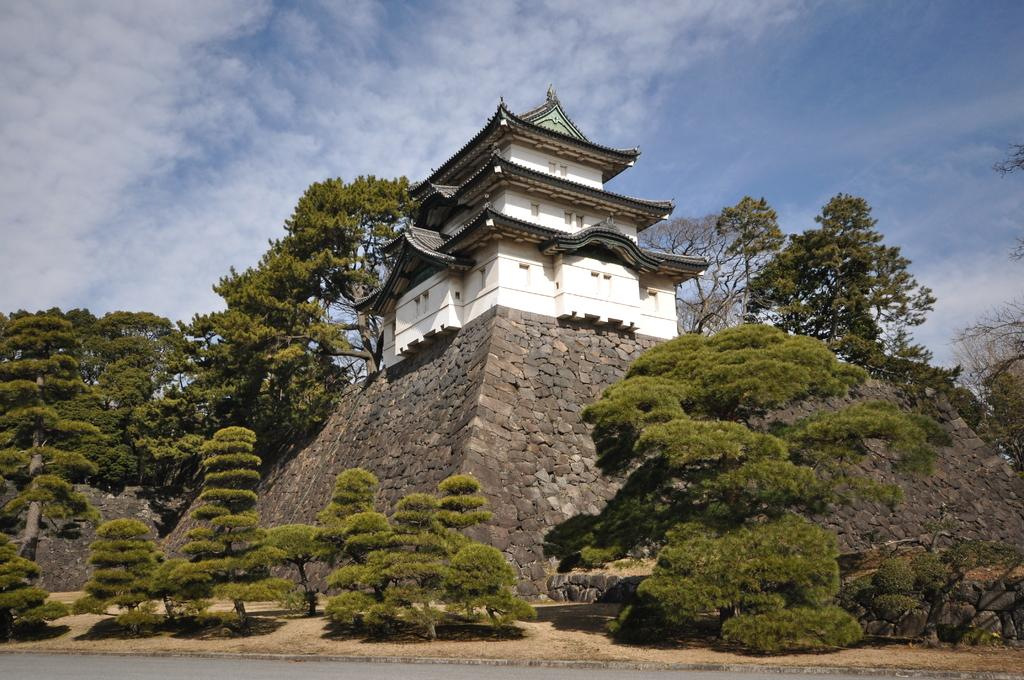What type of structure is located on the fort in the image? There is a building on a fort in the image. What type of vegetation can be seen in the image? There are trees in the image. What is visible in the sky at the top of the image? There are clouds in the sky at the top of the image. What can be seen at the bottom of the image? There is a road visible at the bottom of the image. Can you see any pencils being used to draw the building in the image? There are no pencils visible in the image, and the image is a photograph, not a drawing. Is there a bomb visible in the image? There is no bomb present in the image. 